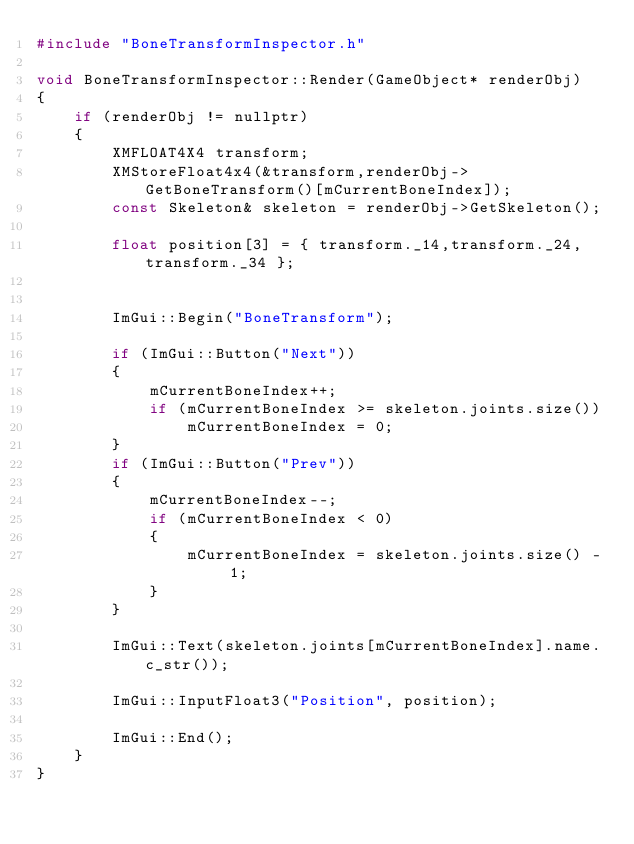<code> <loc_0><loc_0><loc_500><loc_500><_C++_>#include "BoneTransformInspector.h"

void BoneTransformInspector::Render(GameObject* renderObj)
{
	if (renderObj != nullptr)
	{
		XMFLOAT4X4 transform;
		XMStoreFloat4x4(&transform,renderObj->GetBoneTransform()[mCurrentBoneIndex]);
		const Skeleton& skeleton = renderObj->GetSkeleton();

		float position[3] = { transform._14,transform._24,transform._34 };


		ImGui::Begin("BoneTransform");

		if (ImGui::Button("Next"))
		{
			mCurrentBoneIndex++;
			if (mCurrentBoneIndex >= skeleton.joints.size())
				mCurrentBoneIndex = 0;
		}
		if (ImGui::Button("Prev"))
		{
			mCurrentBoneIndex--;
			if (mCurrentBoneIndex < 0)
			{
				mCurrentBoneIndex = skeleton.joints.size() - 1;
			}
		}

		ImGui::Text(skeleton.joints[mCurrentBoneIndex].name.c_str());

		ImGui::InputFloat3("Position", position);

		ImGui::End();
	}
}
</code> 